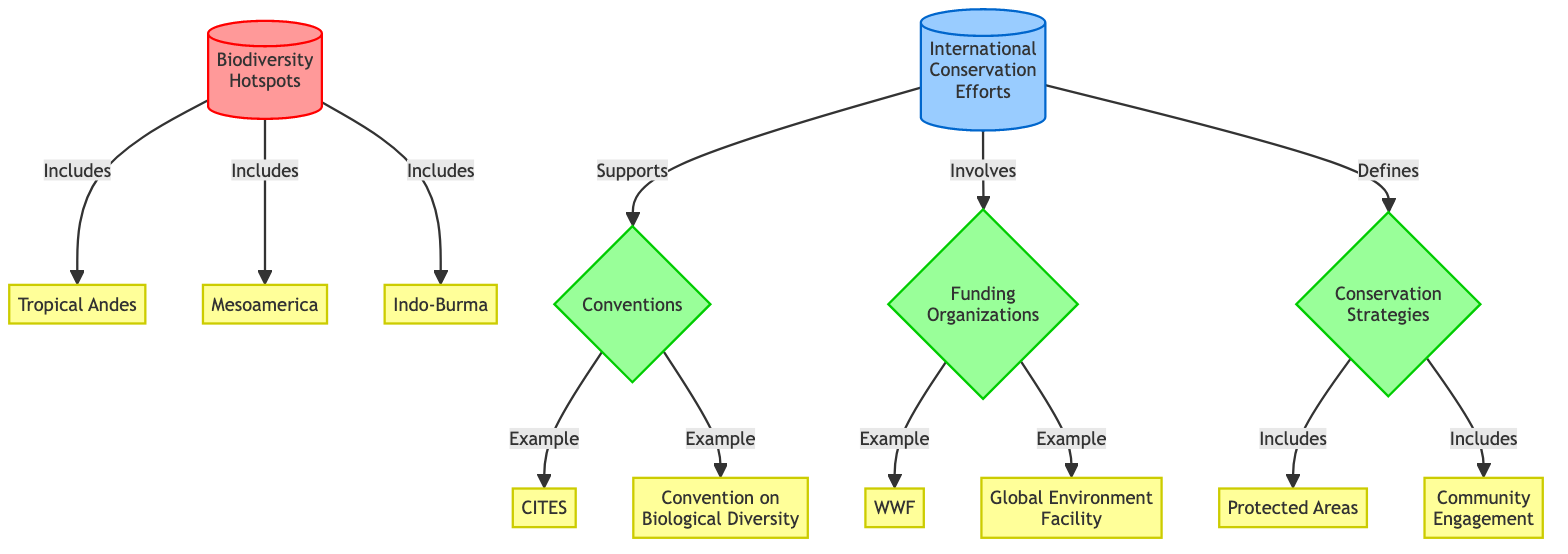What are three specific biodiversity hotspots mentioned in the diagram? The diagram lists three biodiversity hotspots: Tropical Andes, Mesoamerica, and Indo-Burma. These are indicated as examples connected to the Biodiversity Hotspots node.
Answer: Tropical Andes, Mesoamerica, Indo-Burma Which conservation strategy includes Protected Areas? The diagram indicates that Conservation Strategies, which is shown as a node, includes Protected Areas. This relationship is visually represented with an arrow connecting the two.
Answer: Conservation Strategies How many international conservation efforts are represented in the diagram? The diagram identifies one main node titled "International Conservation Efforts" that connects to various strategies, organizations, and conventions, indicating there is a single primary effort node.
Answer: 1 What organization is an example of a funding organization? The node labeled "WWF" represents an example of a funding organization, as indicated in the connections from the Funding Organizations strategy node in the diagram.
Answer: WWF Which convention supports biodiversity hotspots according to the diagram? The diagram presents two conventions that are connected to the Conventions node and both support biodiversity hotspots: CITES and Convention on Biological Diversity. Therefore, both conventions support these efforts.
Answer: CITES, Convention on Biological Diversity What does the arrow from International Conservation Efforts to Conservation Strategies indicate? The arrow indicates that International Conservation Efforts define Conservation Strategies, signifying a strong linking relationship in the context of biodiversity conservation.
Answer: Defines Name one example of community engagement listed in the diagram. According to the diagram, Community Engagement is highlighted as an example within the Conservation Strategies node, showing it as a key strategy in international conservation efforts.
Answer: Community Engagement How many organizations are mentioned as examples of funding organizations in the diagram? The diagram specifies two organizations under the Funding Organizations node, which are WWF and Global Environment Facility, hence there are two examples given.
Answer: 2 What strategy involves the convention CITES? The diagram shows CITES connected to the Conventions strategy, indicating that it involves this international convention aimed at ensuring biodiversity.
Answer: Conventions Which biodiversity hotspot includes Mesoamerica? Mesoamerica is directly indicated in the diagram as part of the Biodiversity Hotspots node, meaning it is included within this category.
Answer: Biodiversity Hotspots 